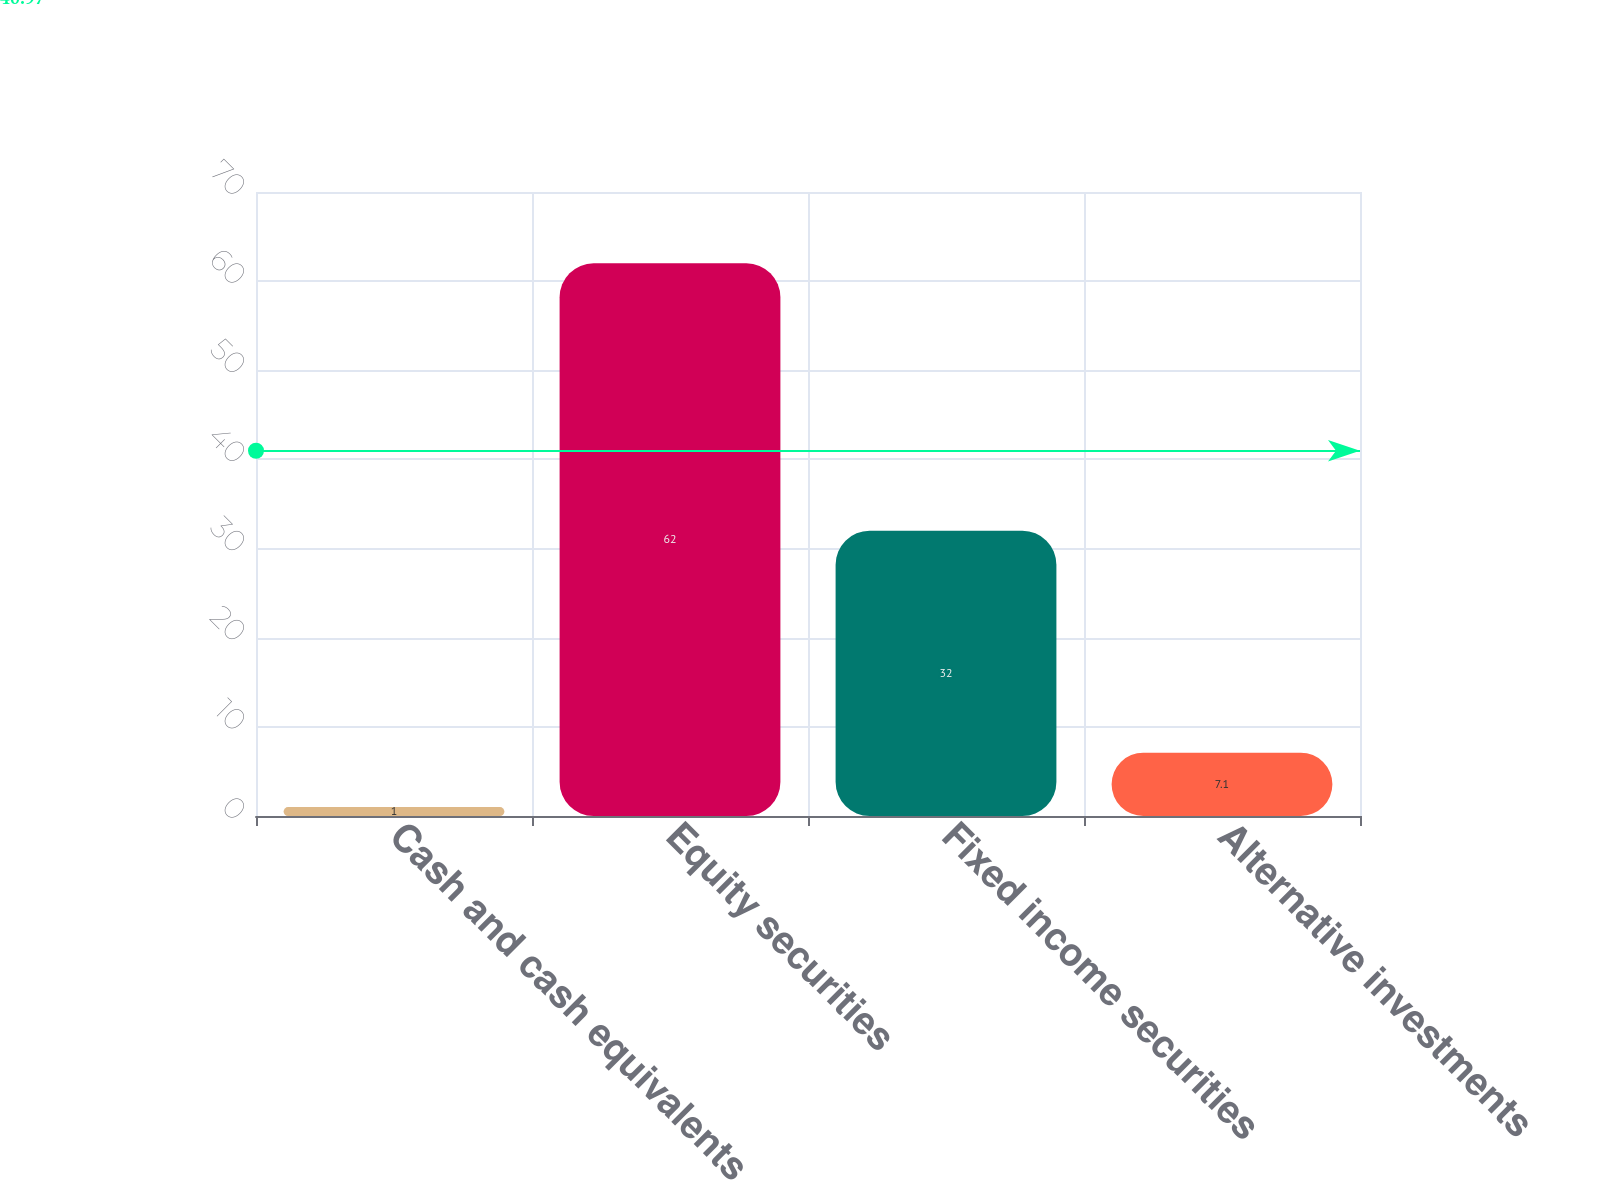Convert chart to OTSL. <chart><loc_0><loc_0><loc_500><loc_500><bar_chart><fcel>Cash and cash equivalents<fcel>Equity securities<fcel>Fixed income securities<fcel>Alternative investments<nl><fcel>1<fcel>62<fcel>32<fcel>7.1<nl></chart> 